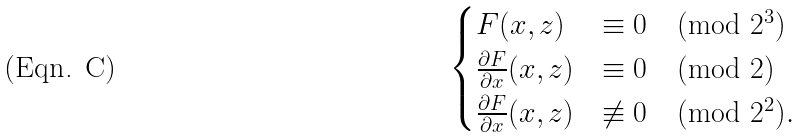Convert formula to latex. <formula><loc_0><loc_0><loc_500><loc_500>\begin{cases} F ( x , z ) & \equiv 0 \pmod { 2 ^ { 3 } } \\ \frac { \partial { F } } { \partial { x } } ( x , z ) & \equiv 0 \pmod { 2 } \\ \frac { \partial { F } } { \partial { x } } ( x , z ) & \not \equiv 0 \pmod { 2 ^ { 2 } } . \end{cases}</formula> 